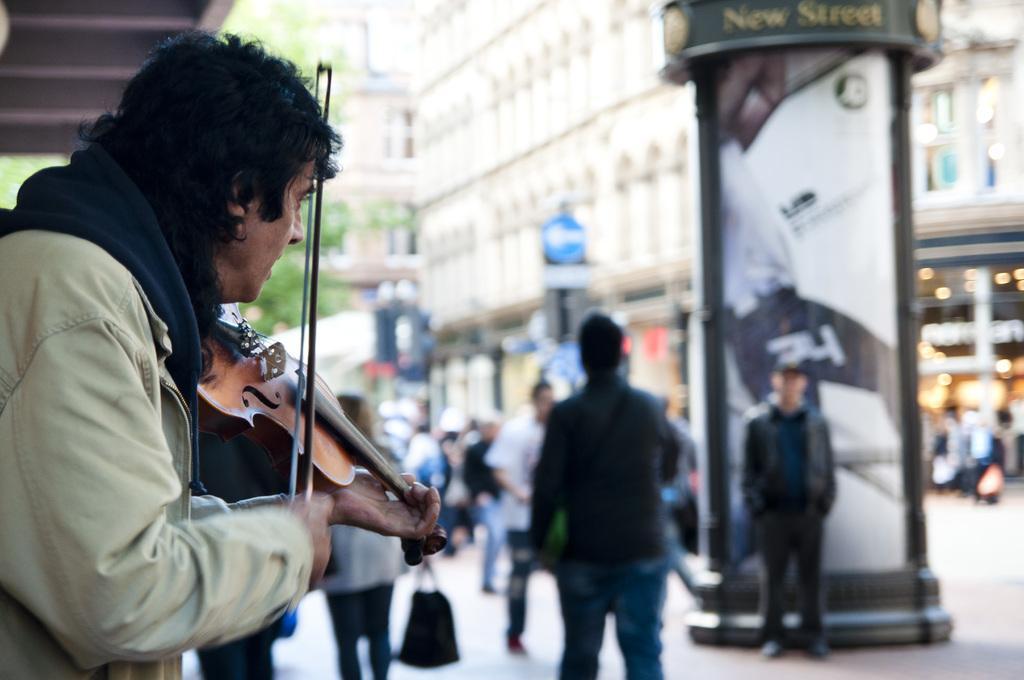Please provide a concise description of this image. In this picture we can see some people standing on the road. Here, there is a person playing the guitar. And on the background there is a building and this is the tree. 